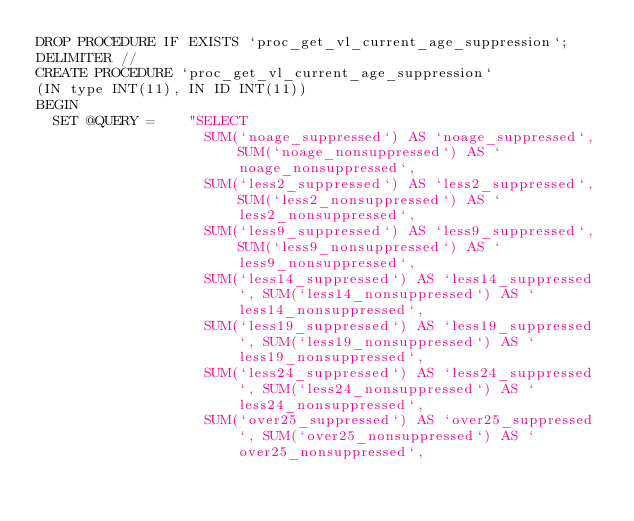<code> <loc_0><loc_0><loc_500><loc_500><_SQL_>DROP PROCEDURE IF EXISTS `proc_get_vl_current_age_suppression`;
DELIMITER //
CREATE PROCEDURE `proc_get_vl_current_age_suppression`
(IN type INT(11), IN ID INT(11))
BEGIN
  SET @QUERY =    "SELECT
                    SUM(`noage_suppressed`) AS `noage_suppressed`, SUM(`noage_nonsuppressed`) AS `noage_nonsuppressed`,
                    SUM(`less2_suppressed`) AS `less2_suppressed`, SUM(`less2_nonsuppressed`) AS `less2_nonsuppressed`,
                    SUM(`less9_suppressed`) AS `less9_suppressed`, SUM(`less9_nonsuppressed`) AS `less9_nonsuppressed`,
                    SUM(`less14_suppressed`) AS `less14_suppressed`, SUM(`less14_nonsuppressed`) AS `less14_nonsuppressed`,
                    SUM(`less19_suppressed`) AS `less19_suppressed`, SUM(`less19_nonsuppressed`) AS `less19_nonsuppressed`,
                    SUM(`less24_suppressed`) AS `less24_suppressed`, SUM(`less24_nonsuppressed`) AS `less24_nonsuppressed`,
                    SUM(`over25_suppressed`) AS `over25_suppressed`, SUM(`over25_nonsuppressed`) AS `over25_nonsuppressed`,</code> 